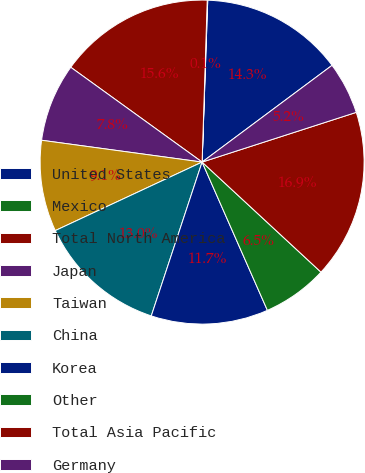<chart> <loc_0><loc_0><loc_500><loc_500><pie_chart><fcel>United States<fcel>Mexico<fcel>Total North America<fcel>Japan<fcel>Taiwan<fcel>China<fcel>Korea<fcel>Other<fcel>Total Asia Pacific<fcel>Germany<nl><fcel>14.26%<fcel>0.05%<fcel>15.55%<fcel>7.8%<fcel>9.1%<fcel>12.97%<fcel>11.68%<fcel>6.51%<fcel>16.85%<fcel>5.22%<nl></chart> 